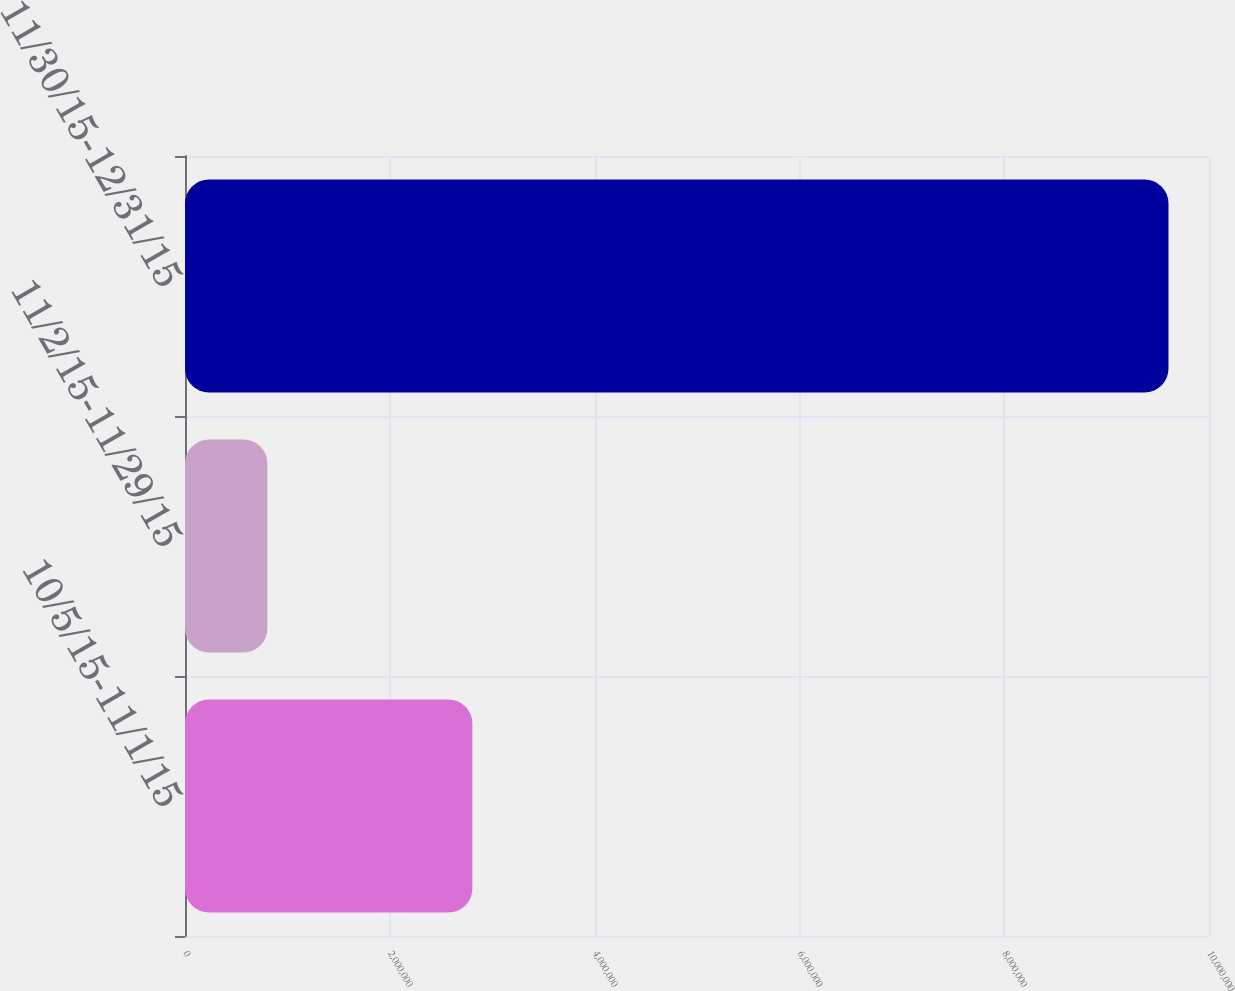Convert chart. <chart><loc_0><loc_0><loc_500><loc_500><bar_chart><fcel>10/5/15-11/1/15<fcel>11/2/15-11/29/15<fcel>11/30/15-12/31/15<nl><fcel>2.80647e+06<fcel>804468<fcel>9.60447e+06<nl></chart> 